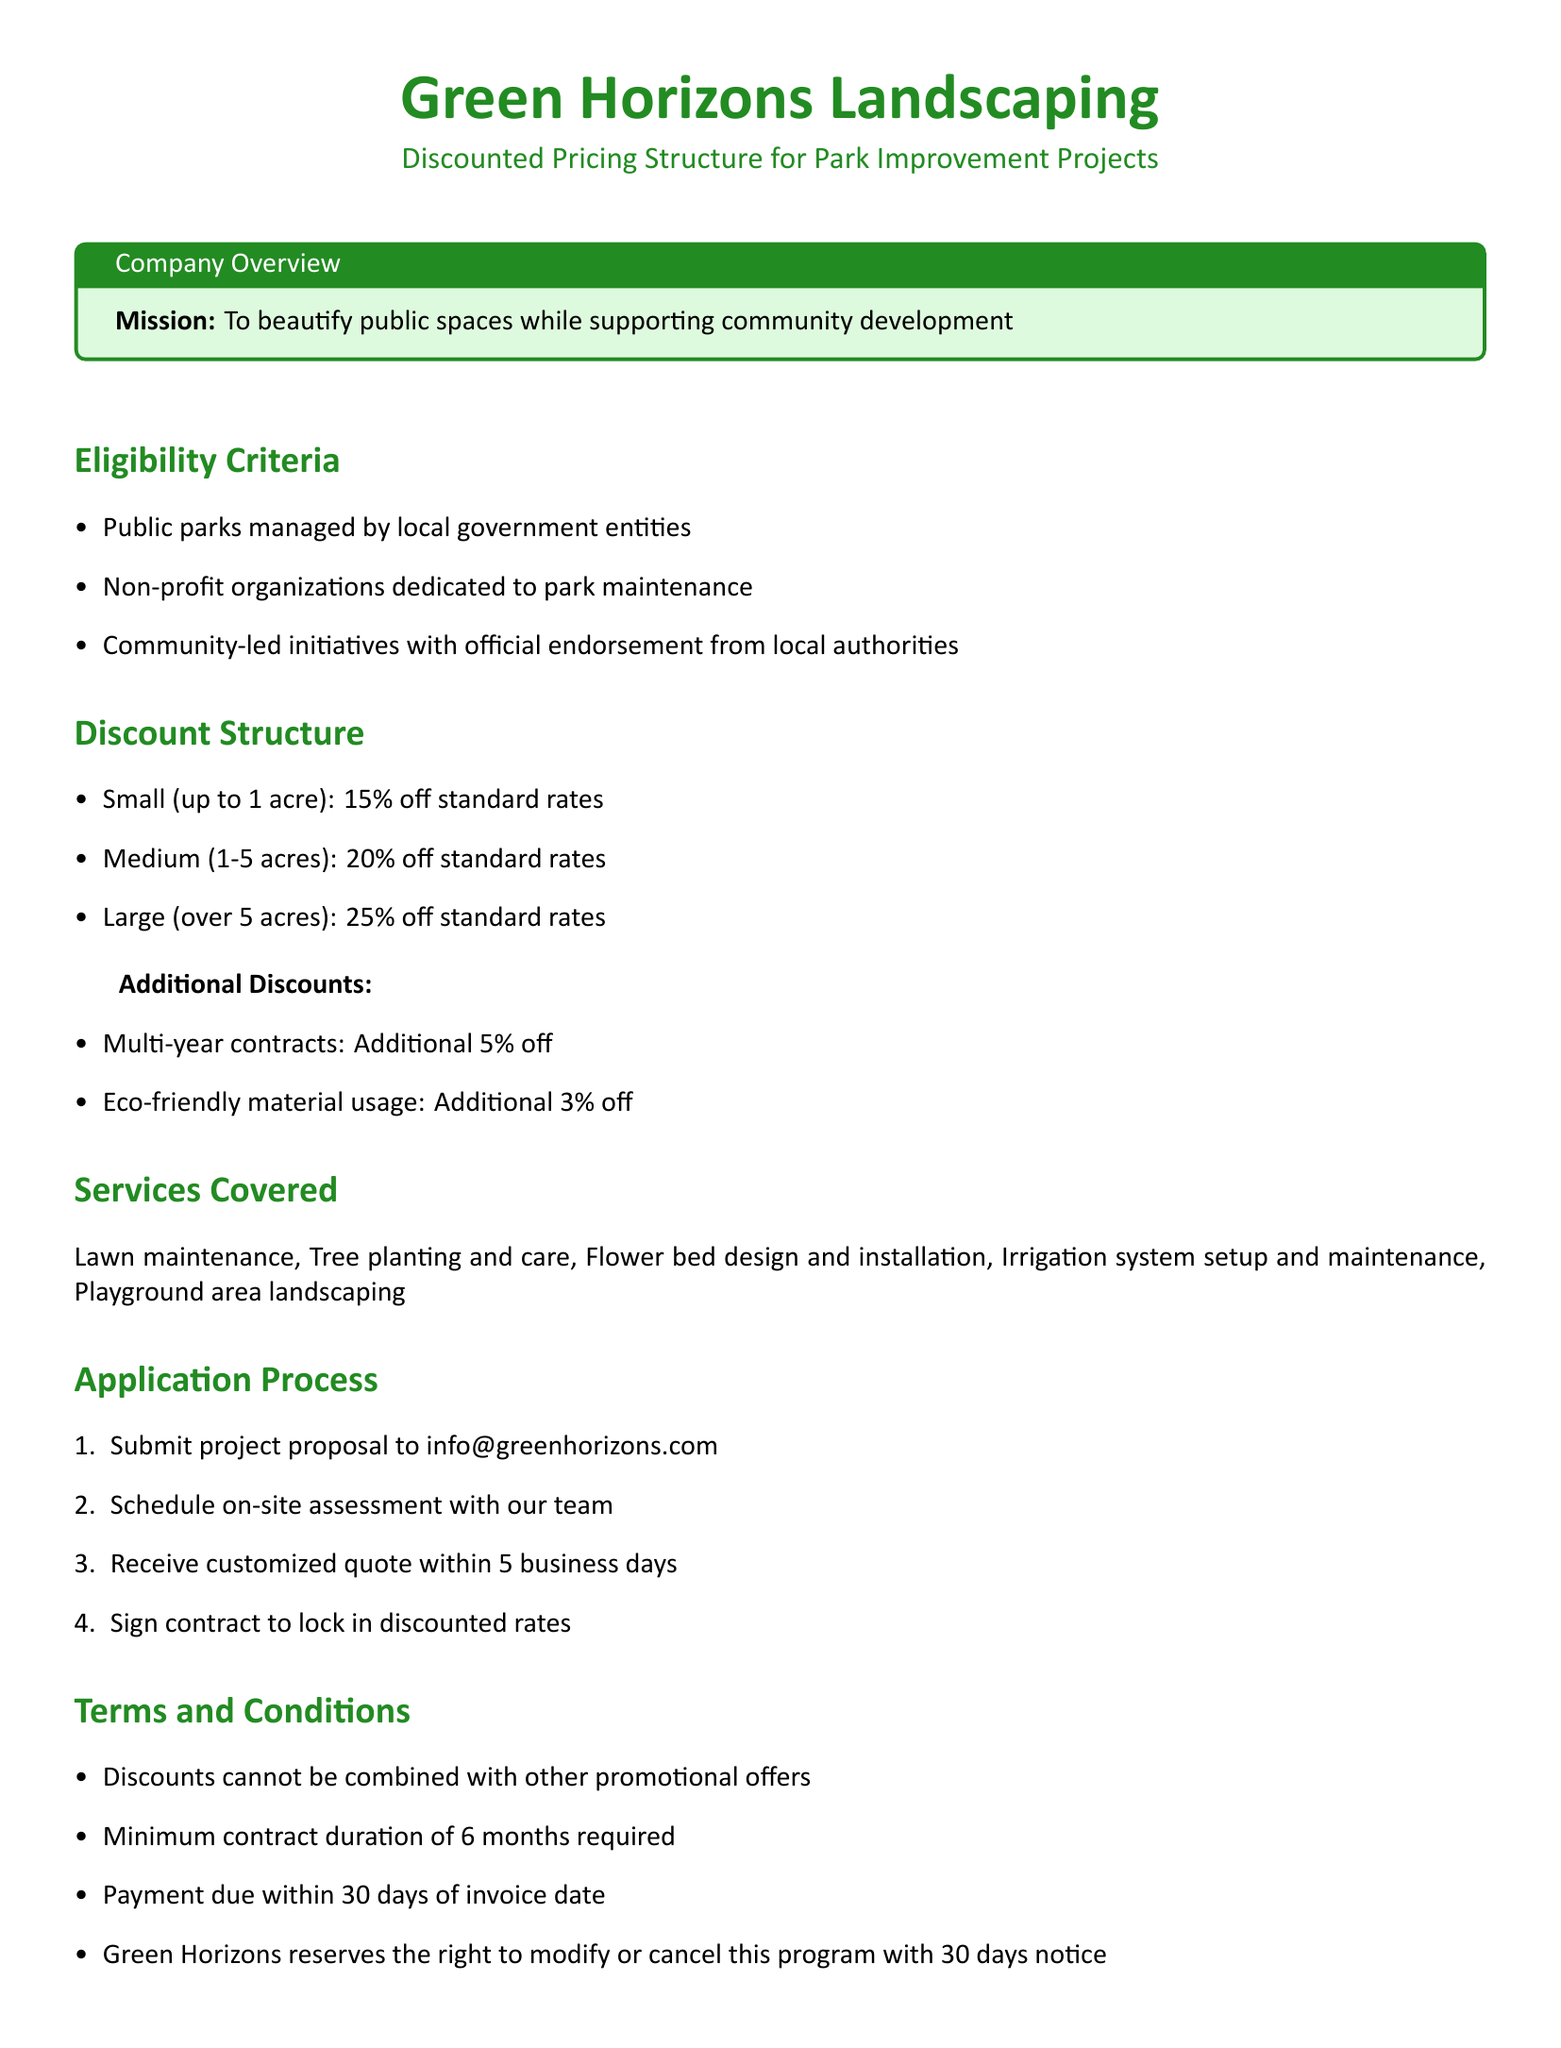What is the discount for small parks? The discount for small parks (up to 1 acre) is specified in the document.
Answer: 15% off Who is eligible for discounted services? The document lists specific groups that are eligible for discounts on services.
Answer: Local government entities, non-profit organizations, community-led initiatives What additional discount can be obtained with eco-friendly material usage? The document mentions a specific additional discount related to eco-friendly practices.
Answer: 3% off What is the minimum contract duration required? The document states a specific time frame for the minimum contract duration in its terms and conditions.
Answer: 6 months How long does it take to receive a customized quote? The document indicates the timeframe for receiving a quote after the on-site assessment.
Answer: 5 business days What is the discount for large parks? The discount for large parks (over 5 acres) is outlined in the discount structure.
Answer: 25% off What must be done first in the application process? The document outlines the steps involved in the application process, starting from a specific action.
Answer: Submit project proposal Which services are covered under the discounted pricing? The document specifies the nature of services that fall under the discounted pricing structure.
Answer: Lawn maintenance, tree planting, flower bed design, irrigation setup, playground landscaping What is the email address for project proposal submissions? The document provides a contact method for project proposal submissions.
Answer: info@greenhorizons.com 